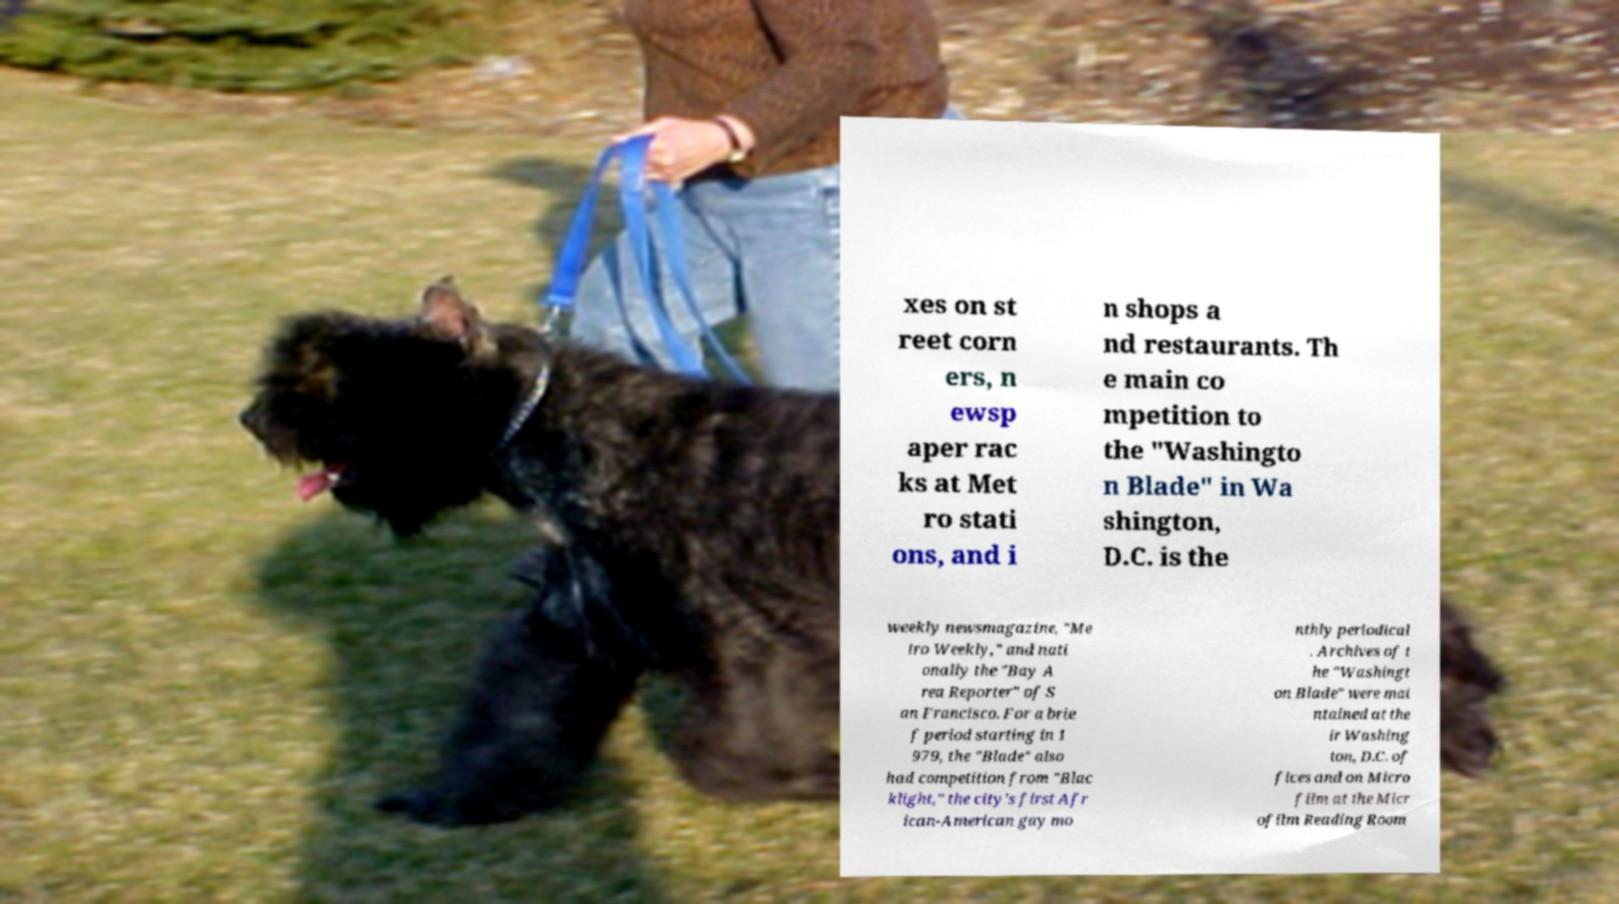I need the written content from this picture converted into text. Can you do that? xes on st reet corn ers, n ewsp aper rac ks at Met ro stati ons, and i n shops a nd restaurants. Th e main co mpetition to the "Washingto n Blade" in Wa shington, D.C. is the weekly newsmagazine, "Me tro Weekly," and nati onally the "Bay A rea Reporter" of S an Francisco. For a brie f period starting in 1 979, the "Blade" also had competition from "Blac klight," the city's first Afr ican-American gay mo nthly periodical . Archives of t he "Washingt on Blade" were mai ntained at the ir Washing ton, D.C. of fices and on Micro film at the Micr ofilm Reading Room 